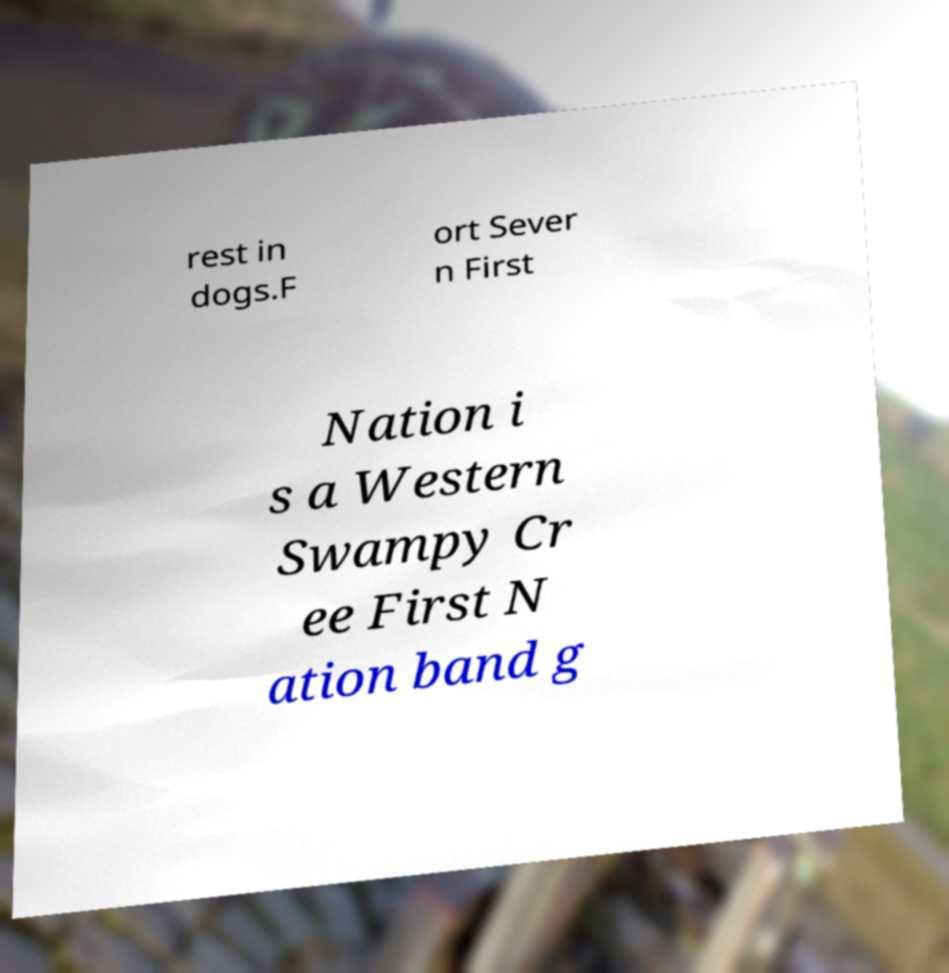For documentation purposes, I need the text within this image transcribed. Could you provide that? rest in dogs.F ort Sever n First Nation i s a Western Swampy Cr ee First N ation band g 